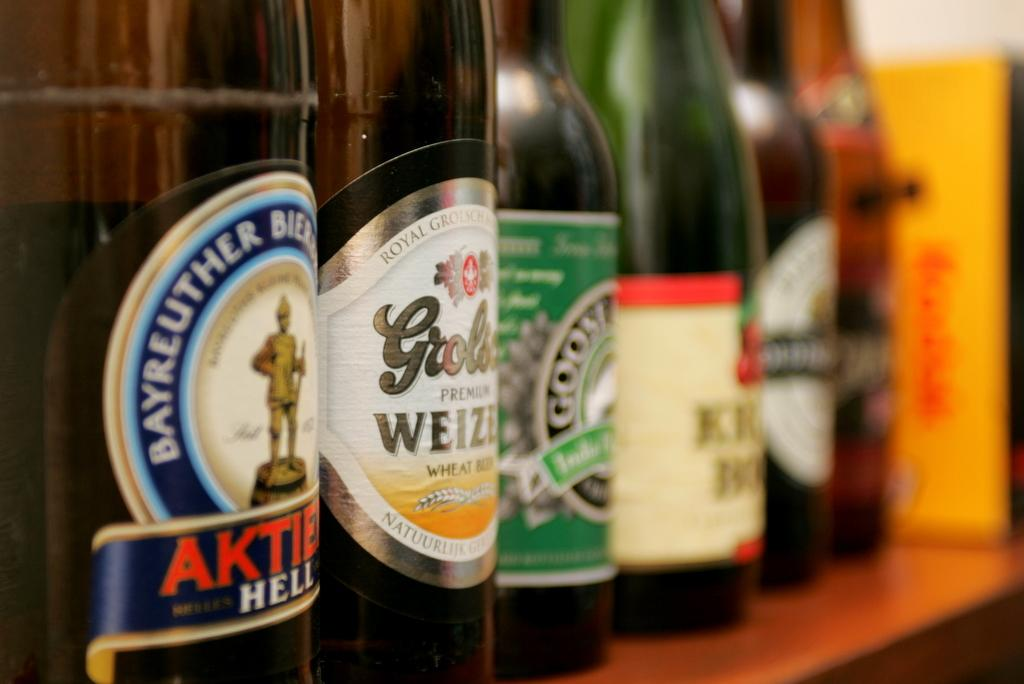<image>
Present a compact description of the photo's key features. A row of bottles include the far left with Hell on the label. 